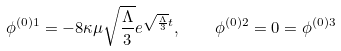Convert formula to latex. <formula><loc_0><loc_0><loc_500><loc_500>\phi ^ { ( 0 ) 1 } = - 8 \kappa \mu \sqrt { \frac { \Lambda } { 3 } } e ^ { \sqrt { \frac { \Lambda } { 3 } } t } , \quad \phi ^ { ( 0 ) 2 } = 0 = \phi ^ { ( 0 ) 3 }</formula> 